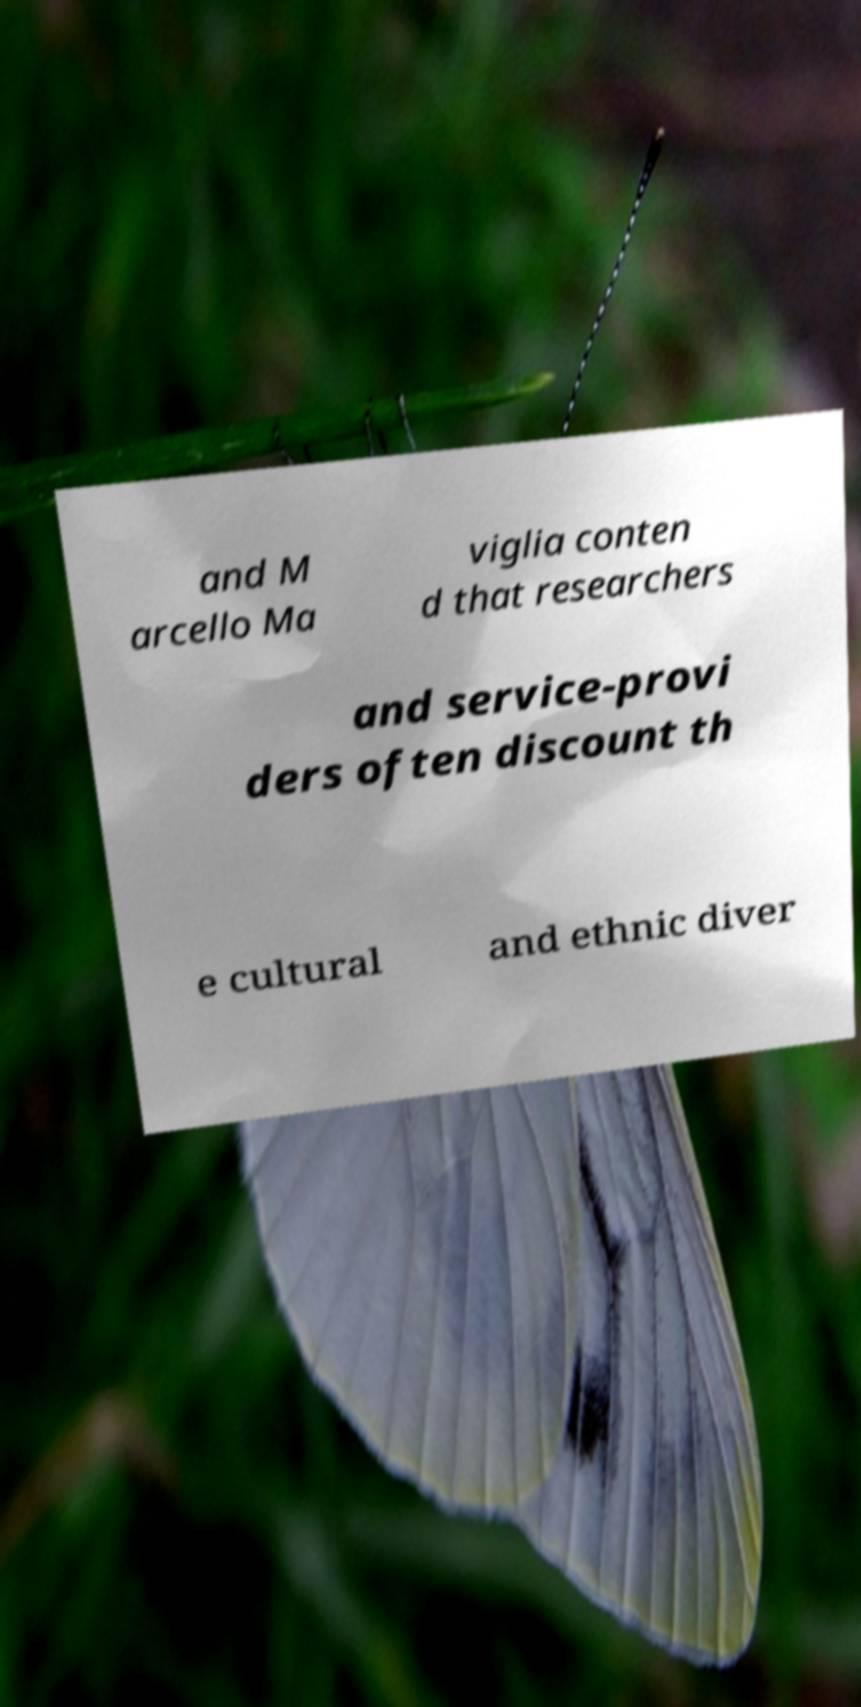Could you extract and type out the text from this image? and M arcello Ma viglia conten d that researchers and service-provi ders often discount th e cultural and ethnic diver 